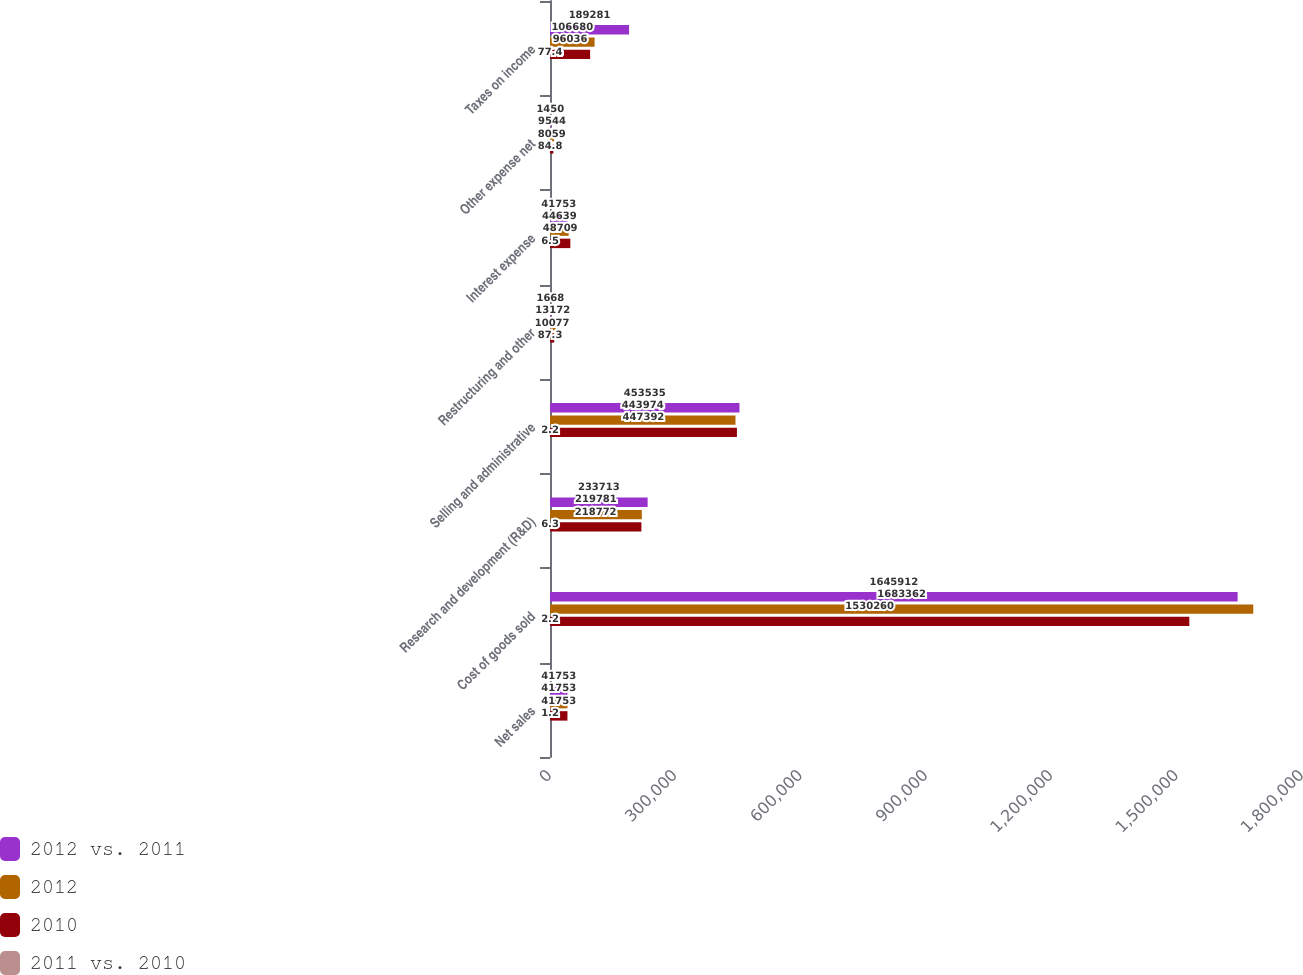<chart> <loc_0><loc_0><loc_500><loc_500><stacked_bar_chart><ecel><fcel>Net sales<fcel>Cost of goods sold<fcel>Research and development (R&D)<fcel>Selling and administrative<fcel>Restructuring and other<fcel>Interest expense<fcel>Other expense net<fcel>Taxes on income<nl><fcel>2012 vs. 2011<fcel>41753<fcel>1.64591e+06<fcel>233713<fcel>453535<fcel>1668<fcel>41753<fcel>1450<fcel>189281<nl><fcel>2012<fcel>41753<fcel>1.68336e+06<fcel>219781<fcel>443974<fcel>13172<fcel>44639<fcel>9544<fcel>106680<nl><fcel>2010<fcel>41753<fcel>1.53026e+06<fcel>218772<fcel>447392<fcel>10077<fcel>48709<fcel>8059<fcel>96036<nl><fcel>2011 vs. 2010<fcel>1.2<fcel>2.2<fcel>6.3<fcel>2.2<fcel>87.3<fcel>6.5<fcel>84.8<fcel>77.4<nl></chart> 